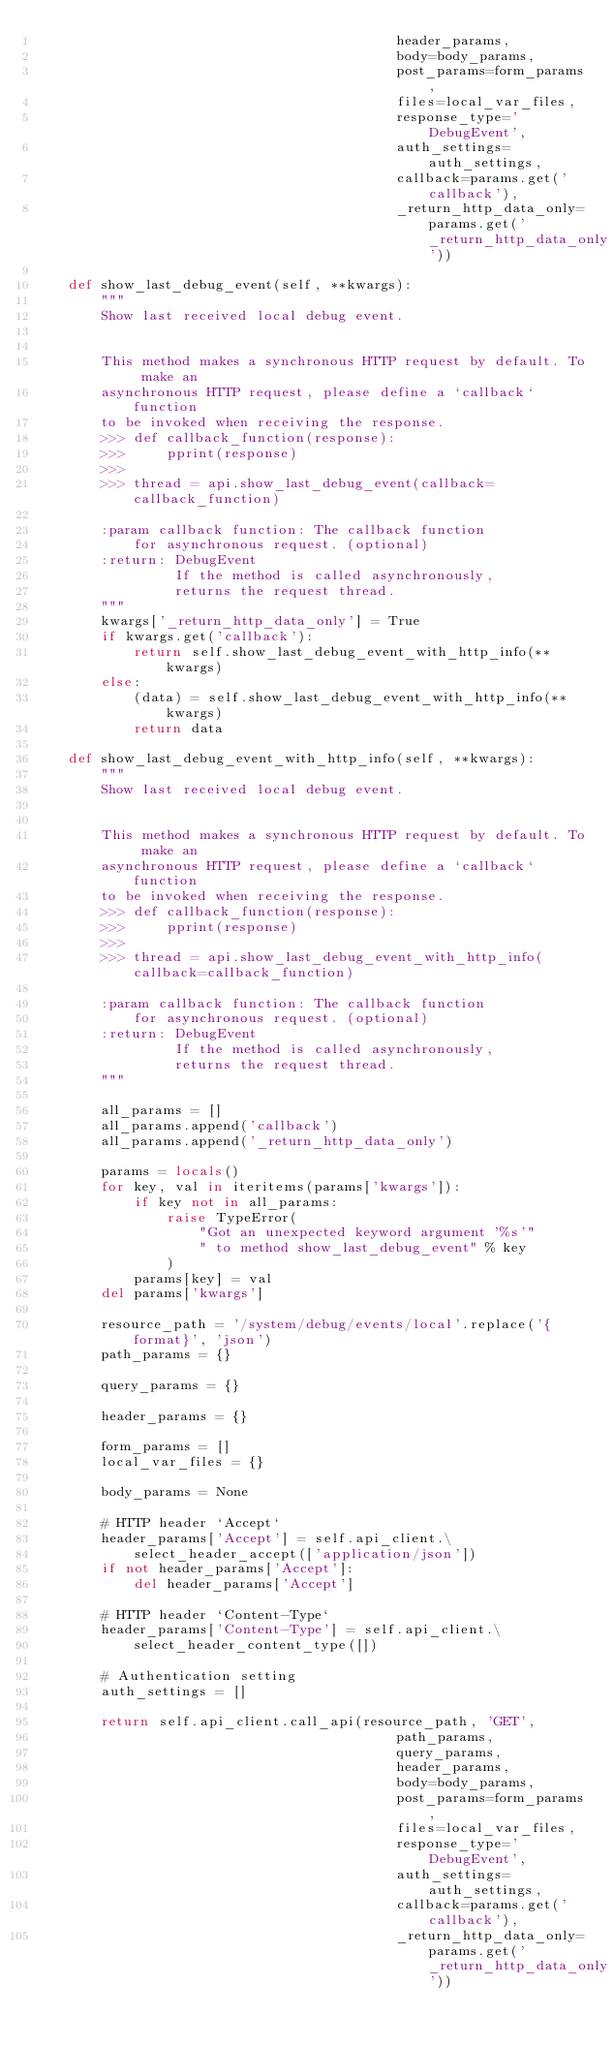Convert code to text. <code><loc_0><loc_0><loc_500><loc_500><_Python_>                                            header_params,
                                            body=body_params,
                                            post_params=form_params,
                                            files=local_var_files,
                                            response_type='DebugEvent',
                                            auth_settings=auth_settings,
                                            callback=params.get('callback'),
                                            _return_http_data_only=params.get('_return_http_data_only'))

    def show_last_debug_event(self, **kwargs):
        """
        Show last received local debug event.
        

        This method makes a synchronous HTTP request by default. To make an
        asynchronous HTTP request, please define a `callback` function
        to be invoked when receiving the response.
        >>> def callback_function(response):
        >>>     pprint(response)
        >>>
        >>> thread = api.show_last_debug_event(callback=callback_function)

        :param callback function: The callback function
            for asynchronous request. (optional)
        :return: DebugEvent
                 If the method is called asynchronously,
                 returns the request thread.
        """
        kwargs['_return_http_data_only'] = True
        if kwargs.get('callback'):
            return self.show_last_debug_event_with_http_info(**kwargs)
        else:
            (data) = self.show_last_debug_event_with_http_info(**kwargs)
            return data

    def show_last_debug_event_with_http_info(self, **kwargs):
        """
        Show last received local debug event.
        

        This method makes a synchronous HTTP request by default. To make an
        asynchronous HTTP request, please define a `callback` function
        to be invoked when receiving the response.
        >>> def callback_function(response):
        >>>     pprint(response)
        >>>
        >>> thread = api.show_last_debug_event_with_http_info(callback=callback_function)

        :param callback function: The callback function
            for asynchronous request. (optional)
        :return: DebugEvent
                 If the method is called asynchronously,
                 returns the request thread.
        """

        all_params = []
        all_params.append('callback')
        all_params.append('_return_http_data_only')

        params = locals()
        for key, val in iteritems(params['kwargs']):
            if key not in all_params:
                raise TypeError(
                    "Got an unexpected keyword argument '%s'"
                    " to method show_last_debug_event" % key
                )
            params[key] = val
        del params['kwargs']

        resource_path = '/system/debug/events/local'.replace('{format}', 'json')
        path_params = {}

        query_params = {}

        header_params = {}

        form_params = []
        local_var_files = {}

        body_params = None

        # HTTP header `Accept`
        header_params['Accept'] = self.api_client.\
            select_header_accept(['application/json'])
        if not header_params['Accept']:
            del header_params['Accept']

        # HTTP header `Content-Type`
        header_params['Content-Type'] = self.api_client.\
            select_header_content_type([])

        # Authentication setting
        auth_settings = []

        return self.api_client.call_api(resource_path, 'GET',
                                            path_params,
                                            query_params,
                                            header_params,
                                            body=body_params,
                                            post_params=form_params,
                                            files=local_var_files,
                                            response_type='DebugEvent',
                                            auth_settings=auth_settings,
                                            callback=params.get('callback'),
                                            _return_http_data_only=params.get('_return_http_data_only'))
</code> 